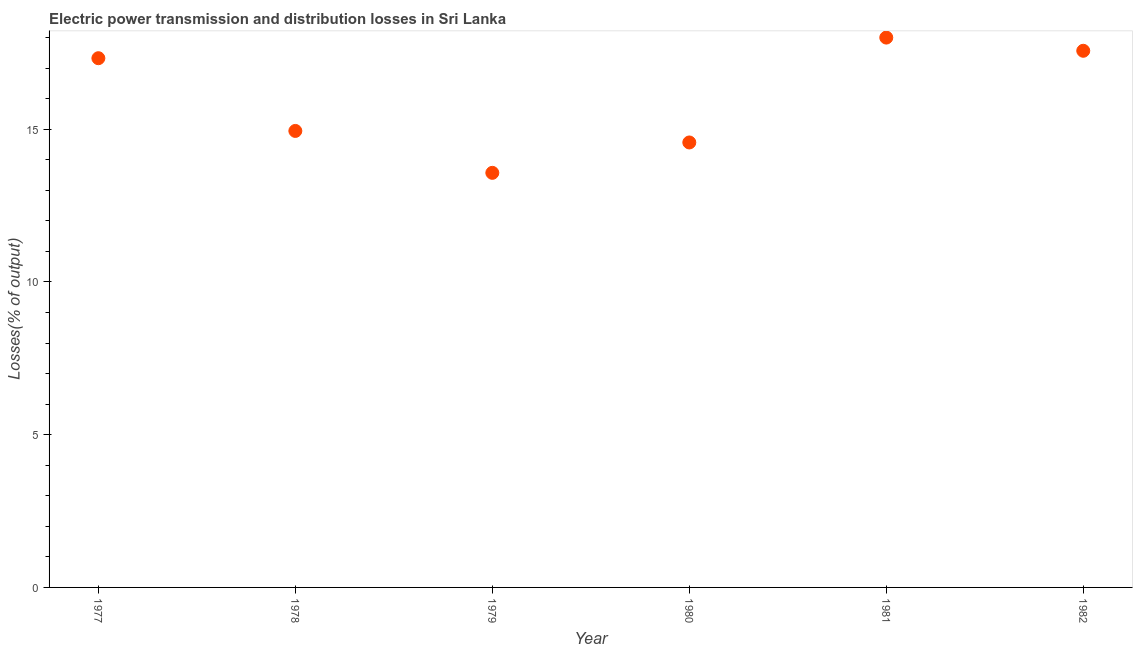What is the electric power transmission and distribution losses in 1981?
Keep it short and to the point. 18. Across all years, what is the maximum electric power transmission and distribution losses?
Provide a succinct answer. 18. Across all years, what is the minimum electric power transmission and distribution losses?
Your response must be concise. 13.57. In which year was the electric power transmission and distribution losses maximum?
Make the answer very short. 1981. In which year was the electric power transmission and distribution losses minimum?
Provide a succinct answer. 1979. What is the sum of the electric power transmission and distribution losses?
Make the answer very short. 95.99. What is the difference between the electric power transmission and distribution losses in 1977 and 1980?
Make the answer very short. 2.76. What is the average electric power transmission and distribution losses per year?
Give a very brief answer. 16. What is the median electric power transmission and distribution losses?
Your answer should be compact. 16.14. Do a majority of the years between 1982 and 1978 (inclusive) have electric power transmission and distribution losses greater than 12 %?
Give a very brief answer. Yes. What is the ratio of the electric power transmission and distribution losses in 1977 to that in 1981?
Your answer should be compact. 0.96. Is the difference between the electric power transmission and distribution losses in 1977 and 1982 greater than the difference between any two years?
Provide a short and direct response. No. What is the difference between the highest and the second highest electric power transmission and distribution losses?
Provide a short and direct response. 0.43. What is the difference between the highest and the lowest electric power transmission and distribution losses?
Offer a terse response. 4.43. In how many years, is the electric power transmission and distribution losses greater than the average electric power transmission and distribution losses taken over all years?
Give a very brief answer. 3. Does the electric power transmission and distribution losses monotonically increase over the years?
Your answer should be very brief. No. Are the values on the major ticks of Y-axis written in scientific E-notation?
Your response must be concise. No. Does the graph contain grids?
Give a very brief answer. No. What is the title of the graph?
Your answer should be very brief. Electric power transmission and distribution losses in Sri Lanka. What is the label or title of the X-axis?
Keep it short and to the point. Year. What is the label or title of the Y-axis?
Make the answer very short. Losses(% of output). What is the Losses(% of output) in 1977?
Your response must be concise. 17.33. What is the Losses(% of output) in 1978?
Keep it short and to the point. 14.95. What is the Losses(% of output) in 1979?
Your answer should be very brief. 13.57. What is the Losses(% of output) in 1980?
Make the answer very short. 14.57. What is the Losses(% of output) in 1981?
Give a very brief answer. 18. What is the Losses(% of output) in 1982?
Offer a very short reply. 17.57. What is the difference between the Losses(% of output) in 1977 and 1978?
Your response must be concise. 2.38. What is the difference between the Losses(% of output) in 1977 and 1979?
Your answer should be very brief. 3.75. What is the difference between the Losses(% of output) in 1977 and 1980?
Your answer should be compact. 2.76. What is the difference between the Losses(% of output) in 1977 and 1981?
Your response must be concise. -0.68. What is the difference between the Losses(% of output) in 1977 and 1982?
Your answer should be compact. -0.24. What is the difference between the Losses(% of output) in 1978 and 1979?
Your response must be concise. 1.37. What is the difference between the Losses(% of output) in 1978 and 1980?
Offer a terse response. 0.38. What is the difference between the Losses(% of output) in 1978 and 1981?
Your response must be concise. -3.06. What is the difference between the Losses(% of output) in 1978 and 1982?
Offer a terse response. -2.62. What is the difference between the Losses(% of output) in 1979 and 1980?
Your answer should be compact. -0.99. What is the difference between the Losses(% of output) in 1979 and 1981?
Offer a very short reply. -4.43. What is the difference between the Losses(% of output) in 1979 and 1982?
Your answer should be compact. -4. What is the difference between the Losses(% of output) in 1980 and 1981?
Make the answer very short. -3.43. What is the difference between the Losses(% of output) in 1980 and 1982?
Keep it short and to the point. -3. What is the difference between the Losses(% of output) in 1981 and 1982?
Ensure brevity in your answer.  0.43. What is the ratio of the Losses(% of output) in 1977 to that in 1978?
Offer a very short reply. 1.16. What is the ratio of the Losses(% of output) in 1977 to that in 1979?
Offer a very short reply. 1.28. What is the ratio of the Losses(% of output) in 1977 to that in 1980?
Your answer should be very brief. 1.19. What is the ratio of the Losses(% of output) in 1978 to that in 1979?
Make the answer very short. 1.1. What is the ratio of the Losses(% of output) in 1978 to that in 1981?
Give a very brief answer. 0.83. What is the ratio of the Losses(% of output) in 1978 to that in 1982?
Your response must be concise. 0.85. What is the ratio of the Losses(% of output) in 1979 to that in 1980?
Keep it short and to the point. 0.93. What is the ratio of the Losses(% of output) in 1979 to that in 1981?
Keep it short and to the point. 0.75. What is the ratio of the Losses(% of output) in 1979 to that in 1982?
Make the answer very short. 0.77. What is the ratio of the Losses(% of output) in 1980 to that in 1981?
Provide a short and direct response. 0.81. What is the ratio of the Losses(% of output) in 1980 to that in 1982?
Offer a terse response. 0.83. What is the ratio of the Losses(% of output) in 1981 to that in 1982?
Ensure brevity in your answer.  1.02. 